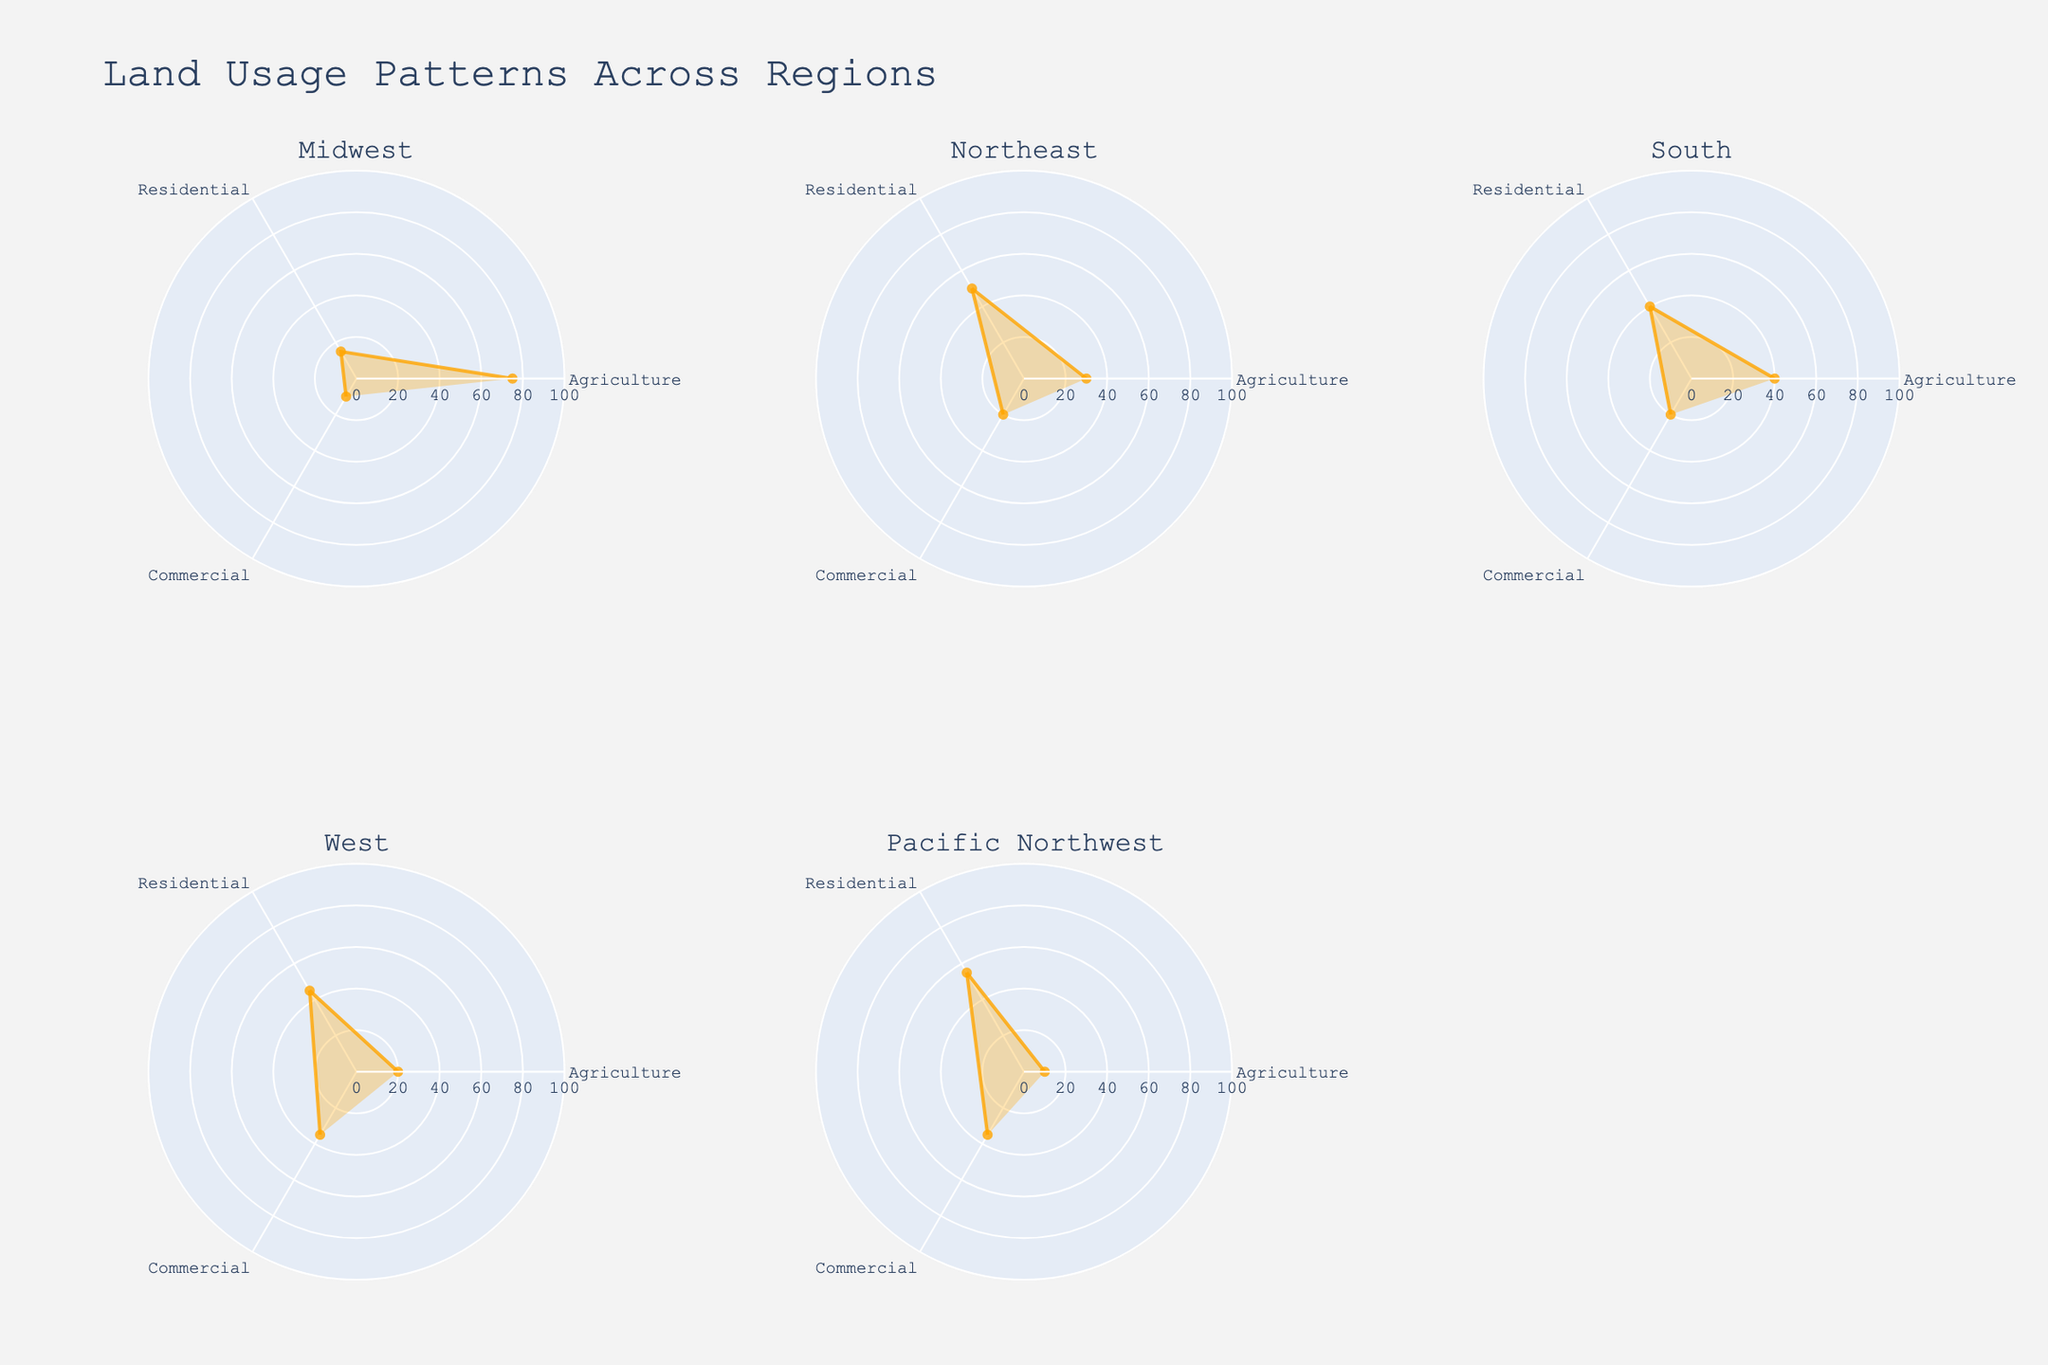What is the title of the figure? The title of the figure can be found at the top of the plot.
Answer: Land Usage Patterns Across Regions What are the different regions represented in the figure? The subplot titles indicate the different regions included in the figure. The regions are Midwest, Northeast, South, West, Pacific Northwest, while the sixth subplot is empty.
Answer: Midwest, Northeast, South, West, Pacific Northwest Which region shows the highest percentage of residential land usage? Look for the region where the residential percentage (denoted by the angle corresponding to 'Residential') is the highest. The Pacific Northwest region has the highest residential percentage at 55%.
Answer: Pacific Northwest How does the percentage of agriculture land usage in the Midwest compare to that in the West? Compare the 'Agriculture' values for the Midwest and West regions. The Midwest has 75%, whereas the West has 20%.
Answer: Midwest is higher What is the overall land usage pattern in the South region? Observe the polar plot for the South region and list the percentages for Agriculture, Residential, and Commercial land usages.
Answer: Agriculture: 40%, Residential: 40%, Commercial: 20% Which regions have the same percentage of commercial land usage? Check the 'Commercial' values for different regions and find those with the same value. The Northeast and South both have 20% commercial land usage.
Answer: Northeast, South What is the average percentage of residential land usage across all regions? Calculate the mean of the residential percentages for all regions. Values are 15, 50, 40, 45, 55. Sum = 205. Average = 205 / 5 = 41%.
Answer: 41% If the agriculture and commercial percentages for the Midwest and Northeast are summed, which has a higher total? Midwest: 75 (Agriculture) + 10 (Commercial) = 85%; Northeast: 30 (Agriculture) + 20 (Commercial) = 50%. Compare these totals.
Answer: Midwest is higher Which region has the most balanced land usage distribution between agriculture, residential, and commercial? Identify the region with the closest percentages across all three categories. The South has 40% Agriculture, 40% Residential, 20% Commercial, which is relatively balanced.
Answer: South 